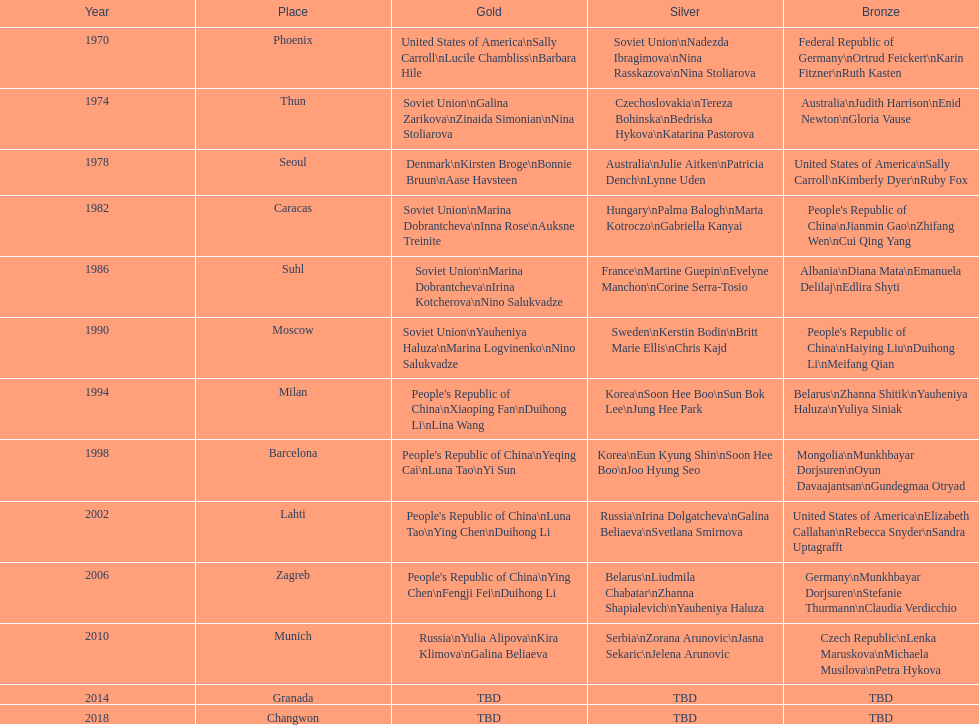Which nation is mentioned the most in the silver column? Korea. 